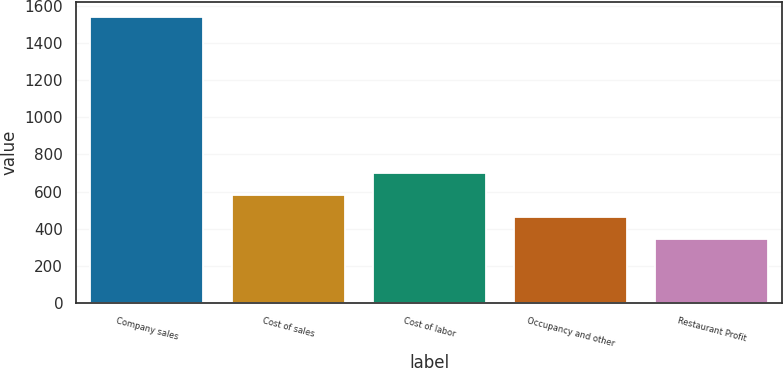Convert chart to OTSL. <chart><loc_0><loc_0><loc_500><loc_500><bar_chart><fcel>Company sales<fcel>Cost of sales<fcel>Cost of labor<fcel>Occupancy and other<fcel>Restaurant Profit<nl><fcel>1541<fcel>582.6<fcel>702.4<fcel>462.8<fcel>343<nl></chart> 